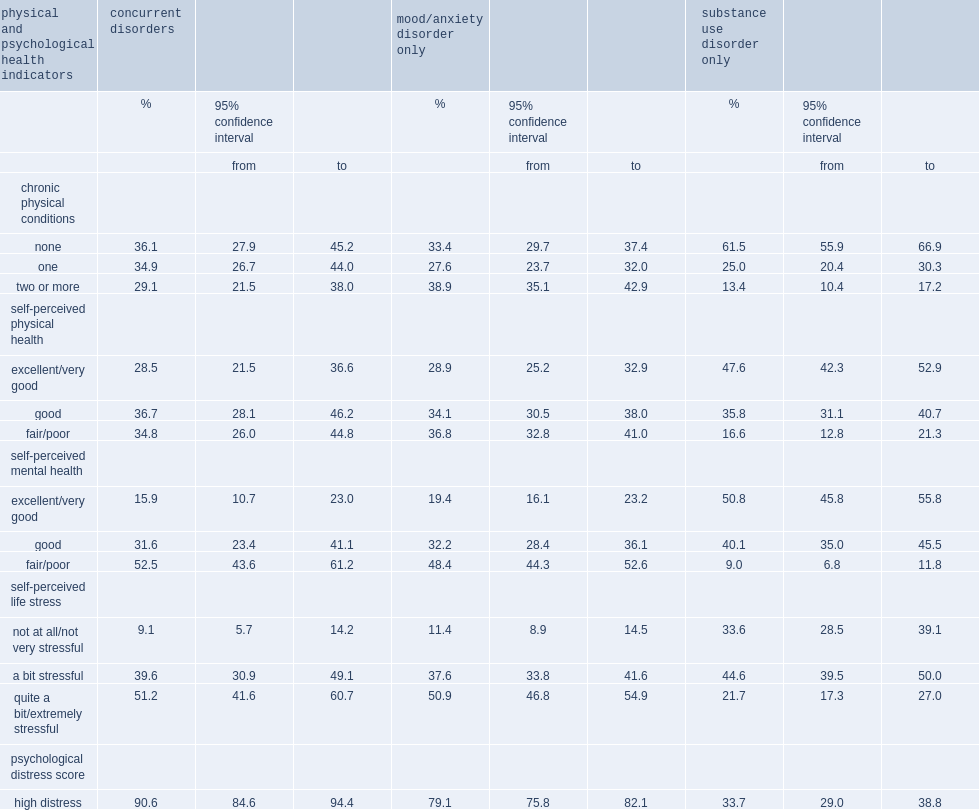What is the percentage of people with concurrent disorders reported that they had at least two chronic conditions? 29.1. Who is likely to had at least two chronic conditions,people with concurrent disorders or those with a mood/anxiety disorder? Mood/anxiety disorder only. Who is likely to had at least two chronic conditions,people with concurrent disorders or those with a substance use disorder? Substance use disorder only. What is the percentage of people with a concurrent disorders perceived their health to be fair or poor? 34.8. What is the percentage of people with a mood/anxiety disorder perceived their health to be fair or poor? 36.8. What is the percentage of people with a ubstance use disorder perceived their health to be fair or poor? 16.6. Who is likely to perceive their mental health to be fair or poor,people with concurrent disorders or those with a substance use disorder? Concurrent disorders. Who is likely to report high life stress,people with concurrent disorders or those with a substance use disorder? Concurrent disorders. Who is likely to report high psychological distress,people with concurrent disorders or those with a mood/anxiety? Concurrent disorders. Who is likely to report high psychological distress,people with concurrent disorders or those with a substance use disorder? Concurrent disorders. 